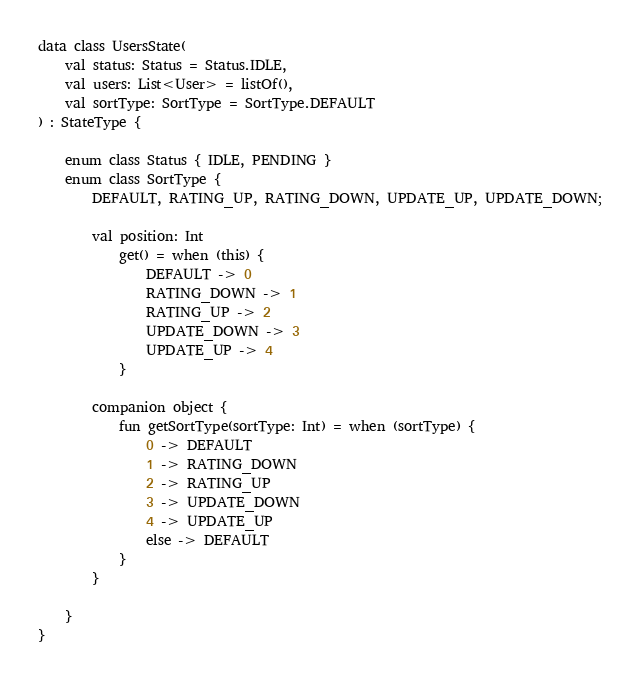<code> <loc_0><loc_0><loc_500><loc_500><_Kotlin_>data class UsersState(
    val status: Status = Status.IDLE,
    val users: List<User> = listOf(),
    val sortType: SortType = SortType.DEFAULT
) : StateType {

    enum class Status { IDLE, PENDING }
    enum class SortType {
        DEFAULT, RATING_UP, RATING_DOWN, UPDATE_UP, UPDATE_DOWN;

        val position: Int
            get() = when (this) {
                DEFAULT -> 0
                RATING_DOWN -> 1
                RATING_UP -> 2
                UPDATE_DOWN -> 3
                UPDATE_UP -> 4
            }

        companion object {
            fun getSortType(sortType: Int) = when (sortType) {
                0 -> DEFAULT
                1 -> RATING_DOWN
                2 -> RATING_UP
                3 -> UPDATE_DOWN
                4 -> UPDATE_UP
                else -> DEFAULT
            }
        }

    }
}</code> 